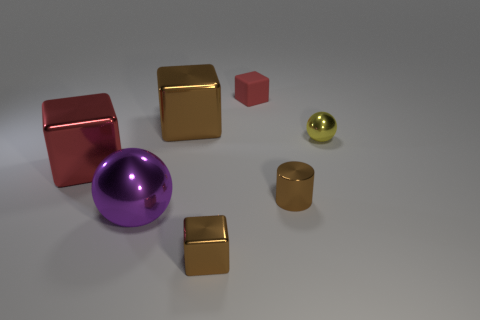What size is the metallic block that is the same color as the small matte thing?
Provide a short and direct response. Large. What is the shape of the large object that is the same color as the tiny metallic block?
Provide a succinct answer. Cube. There is another small shiny thing that is the same shape as the small red object; what color is it?
Offer a terse response. Brown. How many things are either green things or brown metal things?
Provide a short and direct response. 3. Do the thing right of the shiny cylinder and the red object that is on the left side of the small red matte cube have the same shape?
Offer a very short reply. No. The yellow metallic thing that is in front of the matte cube has what shape?
Your response must be concise. Sphere. Are there the same number of tiny brown cylinders left of the purple thing and tiny brown metal cylinders that are behind the brown cylinder?
Provide a short and direct response. Yes. How many things are small blue cylinders or brown things to the left of the tiny brown shiny cube?
Make the answer very short. 1. The brown metallic object that is both left of the small red rubber block and behind the large metal ball has what shape?
Provide a succinct answer. Cube. The tiny block behind the red block in front of the yellow shiny ball is made of what material?
Provide a short and direct response. Rubber. 